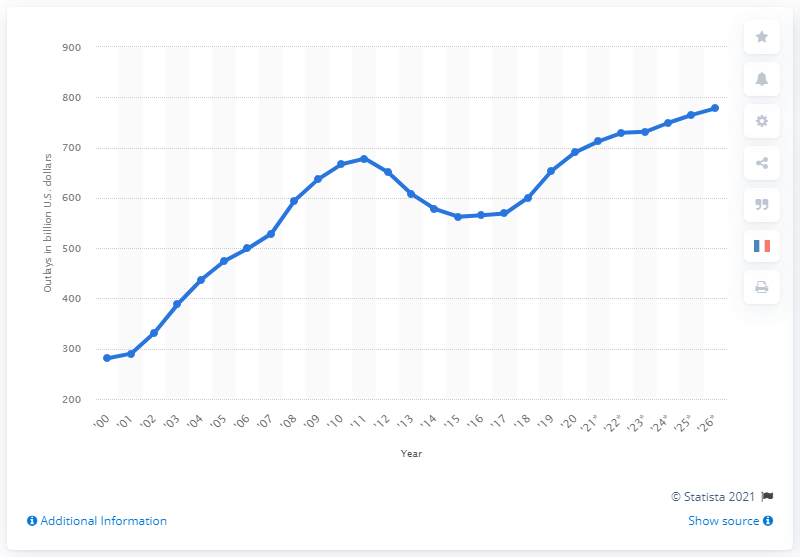Draw attention to some important aspects in this diagram. In 2020, the US Department of Defense spent a total of $690.42 billion. By 2026, the Department of Defense is expected to spend approximately $777.95 billion. 